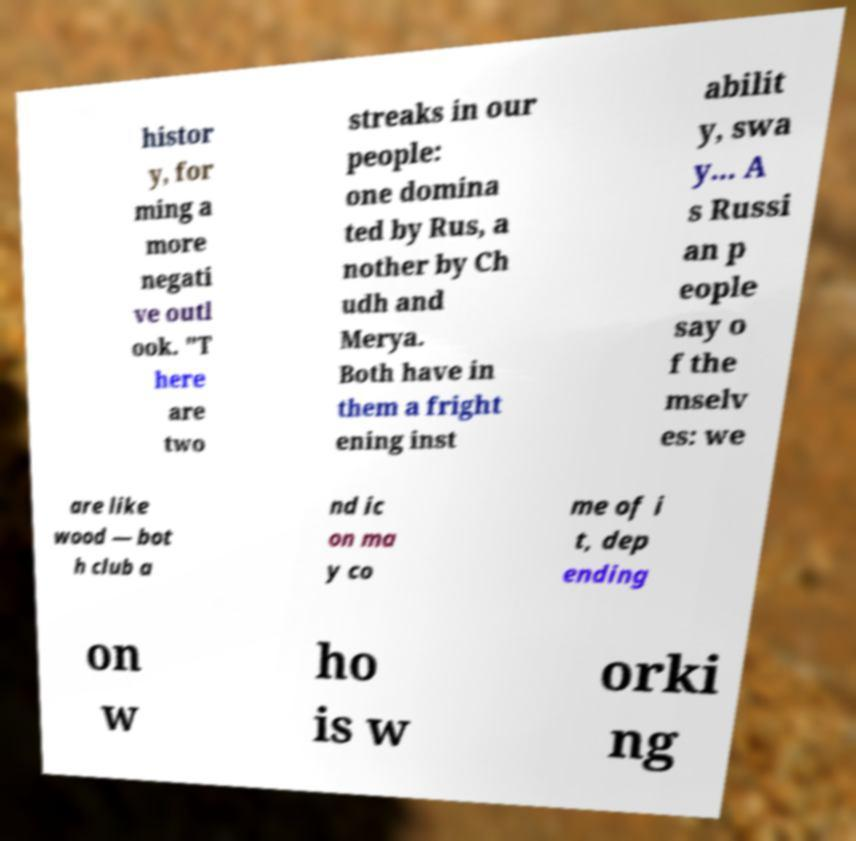Please identify and transcribe the text found in this image. histor y, for ming a more negati ve outl ook. "T here are two streaks in our people: one domina ted by Rus, a nother by Ch udh and Merya. Both have in them a fright ening inst abilit y, swa y... A s Russi an p eople say o f the mselv es: we are like wood — bot h club a nd ic on ma y co me of i t, dep ending on w ho is w orki ng 